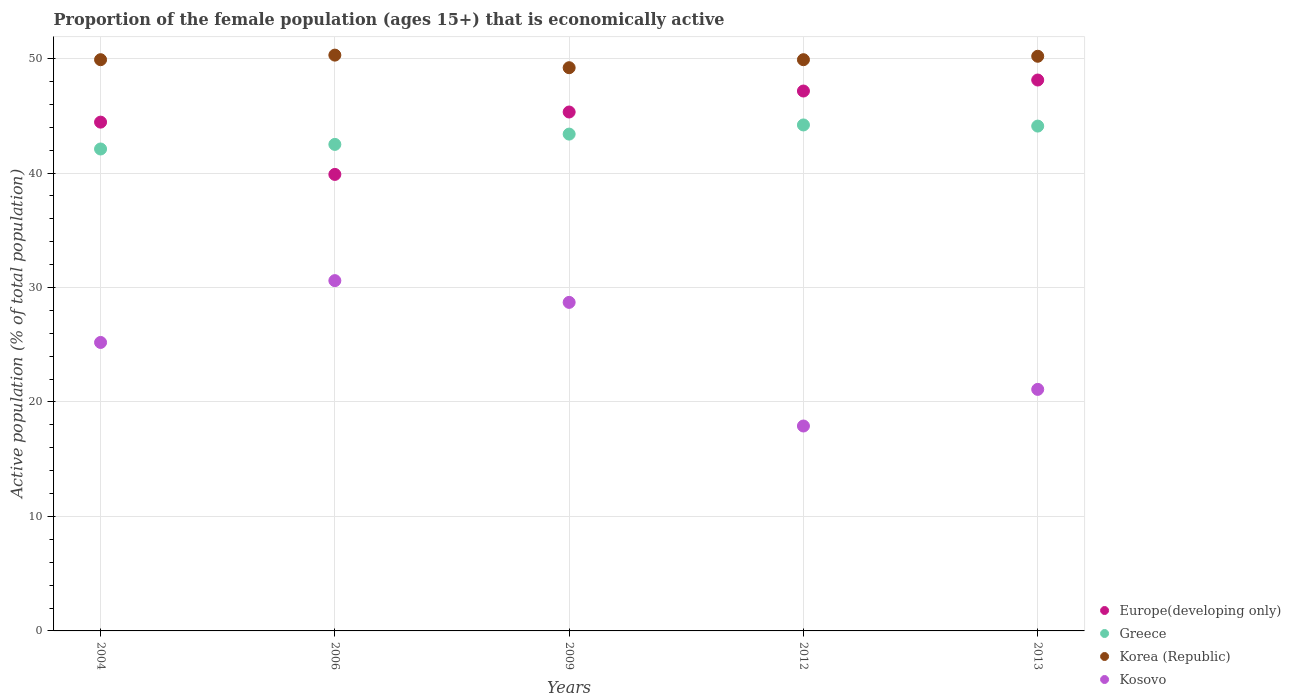What is the proportion of the female population that is economically active in Europe(developing only) in 2004?
Keep it short and to the point. 44.45. Across all years, what is the maximum proportion of the female population that is economically active in Europe(developing only)?
Your answer should be very brief. 48.12. Across all years, what is the minimum proportion of the female population that is economically active in Greece?
Offer a very short reply. 42.1. What is the total proportion of the female population that is economically active in Europe(developing only) in the graph?
Your answer should be compact. 224.94. What is the difference between the proportion of the female population that is economically active in Europe(developing only) in 2004 and that in 2012?
Offer a very short reply. -2.72. What is the difference between the proportion of the female population that is economically active in Kosovo in 2004 and the proportion of the female population that is economically active in Korea (Republic) in 2012?
Keep it short and to the point. -24.7. What is the average proportion of the female population that is economically active in Korea (Republic) per year?
Give a very brief answer. 49.9. In the year 2012, what is the difference between the proportion of the female population that is economically active in Europe(developing only) and proportion of the female population that is economically active in Kosovo?
Provide a succinct answer. 29.26. What is the ratio of the proportion of the female population that is economically active in Greece in 2004 to that in 2012?
Provide a succinct answer. 0.95. Is the proportion of the female population that is economically active in Greece in 2004 less than that in 2012?
Keep it short and to the point. Yes. Is the difference between the proportion of the female population that is economically active in Europe(developing only) in 2004 and 2009 greater than the difference between the proportion of the female population that is economically active in Kosovo in 2004 and 2009?
Provide a short and direct response. Yes. What is the difference between the highest and the second highest proportion of the female population that is economically active in Korea (Republic)?
Provide a short and direct response. 0.1. What is the difference between the highest and the lowest proportion of the female population that is economically active in Kosovo?
Ensure brevity in your answer.  12.7. In how many years, is the proportion of the female population that is economically active in Greece greater than the average proportion of the female population that is economically active in Greece taken over all years?
Your answer should be compact. 3. Is the sum of the proportion of the female population that is economically active in Korea (Republic) in 2009 and 2012 greater than the maximum proportion of the female population that is economically active in Europe(developing only) across all years?
Give a very brief answer. Yes. Is it the case that in every year, the sum of the proportion of the female population that is economically active in Korea (Republic) and proportion of the female population that is economically active in Greece  is greater than the sum of proportion of the female population that is economically active in Europe(developing only) and proportion of the female population that is economically active in Kosovo?
Make the answer very short. Yes. Is it the case that in every year, the sum of the proportion of the female population that is economically active in Kosovo and proportion of the female population that is economically active in Korea (Republic)  is greater than the proportion of the female population that is economically active in Greece?
Your answer should be compact. Yes. Is the proportion of the female population that is economically active in Europe(developing only) strictly greater than the proportion of the female population that is economically active in Greece over the years?
Keep it short and to the point. No. Is the proportion of the female population that is economically active in Kosovo strictly less than the proportion of the female population that is economically active in Greece over the years?
Provide a succinct answer. Yes. How many dotlines are there?
Make the answer very short. 4. How many years are there in the graph?
Make the answer very short. 5. What is the difference between two consecutive major ticks on the Y-axis?
Keep it short and to the point. 10. Are the values on the major ticks of Y-axis written in scientific E-notation?
Provide a succinct answer. No. Does the graph contain any zero values?
Your answer should be very brief. No. Where does the legend appear in the graph?
Keep it short and to the point. Bottom right. How are the legend labels stacked?
Give a very brief answer. Vertical. What is the title of the graph?
Your answer should be very brief. Proportion of the female population (ages 15+) that is economically active. What is the label or title of the Y-axis?
Keep it short and to the point. Active population (% of total population). What is the Active population (% of total population) in Europe(developing only) in 2004?
Your answer should be very brief. 44.45. What is the Active population (% of total population) in Greece in 2004?
Offer a very short reply. 42.1. What is the Active population (% of total population) of Korea (Republic) in 2004?
Give a very brief answer. 49.9. What is the Active population (% of total population) of Kosovo in 2004?
Give a very brief answer. 25.2. What is the Active population (% of total population) in Europe(developing only) in 2006?
Offer a very short reply. 39.88. What is the Active population (% of total population) of Greece in 2006?
Your answer should be compact. 42.5. What is the Active population (% of total population) in Korea (Republic) in 2006?
Provide a short and direct response. 50.3. What is the Active population (% of total population) in Kosovo in 2006?
Your answer should be very brief. 30.6. What is the Active population (% of total population) in Europe(developing only) in 2009?
Your answer should be compact. 45.33. What is the Active population (% of total population) in Greece in 2009?
Your answer should be compact. 43.4. What is the Active population (% of total population) of Korea (Republic) in 2009?
Give a very brief answer. 49.2. What is the Active population (% of total population) in Kosovo in 2009?
Ensure brevity in your answer.  28.7. What is the Active population (% of total population) of Europe(developing only) in 2012?
Offer a very short reply. 47.16. What is the Active population (% of total population) of Greece in 2012?
Provide a succinct answer. 44.2. What is the Active population (% of total population) of Korea (Republic) in 2012?
Provide a short and direct response. 49.9. What is the Active population (% of total population) of Kosovo in 2012?
Offer a terse response. 17.9. What is the Active population (% of total population) in Europe(developing only) in 2013?
Provide a short and direct response. 48.12. What is the Active population (% of total population) of Greece in 2013?
Your answer should be compact. 44.1. What is the Active population (% of total population) in Korea (Republic) in 2013?
Your answer should be compact. 50.2. What is the Active population (% of total population) in Kosovo in 2013?
Make the answer very short. 21.1. Across all years, what is the maximum Active population (% of total population) of Europe(developing only)?
Provide a short and direct response. 48.12. Across all years, what is the maximum Active population (% of total population) of Greece?
Ensure brevity in your answer.  44.2. Across all years, what is the maximum Active population (% of total population) of Korea (Republic)?
Offer a very short reply. 50.3. Across all years, what is the maximum Active population (% of total population) in Kosovo?
Provide a succinct answer. 30.6. Across all years, what is the minimum Active population (% of total population) of Europe(developing only)?
Your answer should be very brief. 39.88. Across all years, what is the minimum Active population (% of total population) of Greece?
Your answer should be compact. 42.1. Across all years, what is the minimum Active population (% of total population) in Korea (Republic)?
Give a very brief answer. 49.2. Across all years, what is the minimum Active population (% of total population) in Kosovo?
Provide a succinct answer. 17.9. What is the total Active population (% of total population) of Europe(developing only) in the graph?
Keep it short and to the point. 224.94. What is the total Active population (% of total population) in Greece in the graph?
Your answer should be compact. 216.3. What is the total Active population (% of total population) in Korea (Republic) in the graph?
Make the answer very short. 249.5. What is the total Active population (% of total population) in Kosovo in the graph?
Make the answer very short. 123.5. What is the difference between the Active population (% of total population) of Europe(developing only) in 2004 and that in 2006?
Make the answer very short. 4.57. What is the difference between the Active population (% of total population) in Greece in 2004 and that in 2006?
Make the answer very short. -0.4. What is the difference between the Active population (% of total population) of Korea (Republic) in 2004 and that in 2006?
Ensure brevity in your answer.  -0.4. What is the difference between the Active population (% of total population) in Kosovo in 2004 and that in 2006?
Make the answer very short. -5.4. What is the difference between the Active population (% of total population) in Europe(developing only) in 2004 and that in 2009?
Ensure brevity in your answer.  -0.88. What is the difference between the Active population (% of total population) in Korea (Republic) in 2004 and that in 2009?
Your answer should be very brief. 0.7. What is the difference between the Active population (% of total population) in Europe(developing only) in 2004 and that in 2012?
Offer a terse response. -2.72. What is the difference between the Active population (% of total population) in Greece in 2004 and that in 2012?
Make the answer very short. -2.1. What is the difference between the Active population (% of total population) of Europe(developing only) in 2004 and that in 2013?
Provide a succinct answer. -3.68. What is the difference between the Active population (% of total population) of Kosovo in 2004 and that in 2013?
Provide a short and direct response. 4.1. What is the difference between the Active population (% of total population) in Europe(developing only) in 2006 and that in 2009?
Your response must be concise. -5.45. What is the difference between the Active population (% of total population) in Greece in 2006 and that in 2009?
Your response must be concise. -0.9. What is the difference between the Active population (% of total population) in Korea (Republic) in 2006 and that in 2009?
Your answer should be compact. 1.1. What is the difference between the Active population (% of total population) of Europe(developing only) in 2006 and that in 2012?
Your response must be concise. -7.29. What is the difference between the Active population (% of total population) in Greece in 2006 and that in 2012?
Ensure brevity in your answer.  -1.7. What is the difference between the Active population (% of total population) in Kosovo in 2006 and that in 2012?
Offer a terse response. 12.7. What is the difference between the Active population (% of total population) of Europe(developing only) in 2006 and that in 2013?
Offer a very short reply. -8.25. What is the difference between the Active population (% of total population) of Korea (Republic) in 2006 and that in 2013?
Make the answer very short. 0.1. What is the difference between the Active population (% of total population) of Europe(developing only) in 2009 and that in 2012?
Provide a succinct answer. -1.83. What is the difference between the Active population (% of total population) of Greece in 2009 and that in 2012?
Provide a succinct answer. -0.8. What is the difference between the Active population (% of total population) of Korea (Republic) in 2009 and that in 2012?
Your answer should be very brief. -0.7. What is the difference between the Active population (% of total population) of Kosovo in 2009 and that in 2012?
Your response must be concise. 10.8. What is the difference between the Active population (% of total population) in Europe(developing only) in 2009 and that in 2013?
Give a very brief answer. -2.79. What is the difference between the Active population (% of total population) in Kosovo in 2009 and that in 2013?
Your answer should be very brief. 7.6. What is the difference between the Active population (% of total population) in Europe(developing only) in 2012 and that in 2013?
Your answer should be compact. -0.96. What is the difference between the Active population (% of total population) in Kosovo in 2012 and that in 2013?
Offer a terse response. -3.2. What is the difference between the Active population (% of total population) of Europe(developing only) in 2004 and the Active population (% of total population) of Greece in 2006?
Keep it short and to the point. 1.95. What is the difference between the Active population (% of total population) of Europe(developing only) in 2004 and the Active population (% of total population) of Korea (Republic) in 2006?
Provide a succinct answer. -5.85. What is the difference between the Active population (% of total population) of Europe(developing only) in 2004 and the Active population (% of total population) of Kosovo in 2006?
Your answer should be compact. 13.85. What is the difference between the Active population (% of total population) in Greece in 2004 and the Active population (% of total population) in Kosovo in 2006?
Offer a terse response. 11.5. What is the difference between the Active population (% of total population) in Korea (Republic) in 2004 and the Active population (% of total population) in Kosovo in 2006?
Provide a short and direct response. 19.3. What is the difference between the Active population (% of total population) in Europe(developing only) in 2004 and the Active population (% of total population) in Greece in 2009?
Your response must be concise. 1.05. What is the difference between the Active population (% of total population) in Europe(developing only) in 2004 and the Active population (% of total population) in Korea (Republic) in 2009?
Your answer should be very brief. -4.75. What is the difference between the Active population (% of total population) in Europe(developing only) in 2004 and the Active population (% of total population) in Kosovo in 2009?
Keep it short and to the point. 15.75. What is the difference between the Active population (% of total population) in Korea (Republic) in 2004 and the Active population (% of total population) in Kosovo in 2009?
Keep it short and to the point. 21.2. What is the difference between the Active population (% of total population) of Europe(developing only) in 2004 and the Active population (% of total population) of Greece in 2012?
Offer a very short reply. 0.25. What is the difference between the Active population (% of total population) of Europe(developing only) in 2004 and the Active population (% of total population) of Korea (Republic) in 2012?
Ensure brevity in your answer.  -5.45. What is the difference between the Active population (% of total population) in Europe(developing only) in 2004 and the Active population (% of total population) in Kosovo in 2012?
Keep it short and to the point. 26.55. What is the difference between the Active population (% of total population) in Greece in 2004 and the Active population (% of total population) in Korea (Republic) in 2012?
Ensure brevity in your answer.  -7.8. What is the difference between the Active population (% of total population) in Greece in 2004 and the Active population (% of total population) in Kosovo in 2012?
Provide a short and direct response. 24.2. What is the difference between the Active population (% of total population) in Europe(developing only) in 2004 and the Active population (% of total population) in Greece in 2013?
Provide a short and direct response. 0.35. What is the difference between the Active population (% of total population) of Europe(developing only) in 2004 and the Active population (% of total population) of Korea (Republic) in 2013?
Offer a terse response. -5.75. What is the difference between the Active population (% of total population) in Europe(developing only) in 2004 and the Active population (% of total population) in Kosovo in 2013?
Provide a short and direct response. 23.35. What is the difference between the Active population (% of total population) in Greece in 2004 and the Active population (% of total population) in Kosovo in 2013?
Offer a very short reply. 21. What is the difference between the Active population (% of total population) in Korea (Republic) in 2004 and the Active population (% of total population) in Kosovo in 2013?
Your response must be concise. 28.8. What is the difference between the Active population (% of total population) of Europe(developing only) in 2006 and the Active population (% of total population) of Greece in 2009?
Your answer should be compact. -3.52. What is the difference between the Active population (% of total population) of Europe(developing only) in 2006 and the Active population (% of total population) of Korea (Republic) in 2009?
Make the answer very short. -9.32. What is the difference between the Active population (% of total population) in Europe(developing only) in 2006 and the Active population (% of total population) in Kosovo in 2009?
Provide a succinct answer. 11.18. What is the difference between the Active population (% of total population) of Korea (Republic) in 2006 and the Active population (% of total population) of Kosovo in 2009?
Ensure brevity in your answer.  21.6. What is the difference between the Active population (% of total population) of Europe(developing only) in 2006 and the Active population (% of total population) of Greece in 2012?
Your answer should be compact. -4.32. What is the difference between the Active population (% of total population) of Europe(developing only) in 2006 and the Active population (% of total population) of Korea (Republic) in 2012?
Offer a very short reply. -10.02. What is the difference between the Active population (% of total population) of Europe(developing only) in 2006 and the Active population (% of total population) of Kosovo in 2012?
Offer a terse response. 21.98. What is the difference between the Active population (% of total population) in Greece in 2006 and the Active population (% of total population) in Kosovo in 2012?
Offer a very short reply. 24.6. What is the difference between the Active population (% of total population) in Korea (Republic) in 2006 and the Active population (% of total population) in Kosovo in 2012?
Offer a terse response. 32.4. What is the difference between the Active population (% of total population) of Europe(developing only) in 2006 and the Active population (% of total population) of Greece in 2013?
Give a very brief answer. -4.22. What is the difference between the Active population (% of total population) of Europe(developing only) in 2006 and the Active population (% of total population) of Korea (Republic) in 2013?
Ensure brevity in your answer.  -10.32. What is the difference between the Active population (% of total population) in Europe(developing only) in 2006 and the Active population (% of total population) in Kosovo in 2013?
Give a very brief answer. 18.78. What is the difference between the Active population (% of total population) of Greece in 2006 and the Active population (% of total population) of Kosovo in 2013?
Provide a short and direct response. 21.4. What is the difference between the Active population (% of total population) in Korea (Republic) in 2006 and the Active population (% of total population) in Kosovo in 2013?
Your answer should be very brief. 29.2. What is the difference between the Active population (% of total population) of Europe(developing only) in 2009 and the Active population (% of total population) of Greece in 2012?
Your response must be concise. 1.13. What is the difference between the Active population (% of total population) in Europe(developing only) in 2009 and the Active population (% of total population) in Korea (Republic) in 2012?
Your answer should be very brief. -4.57. What is the difference between the Active population (% of total population) in Europe(developing only) in 2009 and the Active population (% of total population) in Kosovo in 2012?
Provide a short and direct response. 27.43. What is the difference between the Active population (% of total population) in Greece in 2009 and the Active population (% of total population) in Korea (Republic) in 2012?
Keep it short and to the point. -6.5. What is the difference between the Active population (% of total population) in Korea (Republic) in 2009 and the Active population (% of total population) in Kosovo in 2012?
Offer a terse response. 31.3. What is the difference between the Active population (% of total population) in Europe(developing only) in 2009 and the Active population (% of total population) in Greece in 2013?
Keep it short and to the point. 1.23. What is the difference between the Active population (% of total population) of Europe(developing only) in 2009 and the Active population (% of total population) of Korea (Republic) in 2013?
Provide a succinct answer. -4.87. What is the difference between the Active population (% of total population) in Europe(developing only) in 2009 and the Active population (% of total population) in Kosovo in 2013?
Give a very brief answer. 24.23. What is the difference between the Active population (% of total population) of Greece in 2009 and the Active population (% of total population) of Kosovo in 2013?
Your answer should be very brief. 22.3. What is the difference between the Active population (% of total population) in Korea (Republic) in 2009 and the Active population (% of total population) in Kosovo in 2013?
Offer a terse response. 28.1. What is the difference between the Active population (% of total population) of Europe(developing only) in 2012 and the Active population (% of total population) of Greece in 2013?
Offer a terse response. 3.06. What is the difference between the Active population (% of total population) in Europe(developing only) in 2012 and the Active population (% of total population) in Korea (Republic) in 2013?
Your response must be concise. -3.04. What is the difference between the Active population (% of total population) of Europe(developing only) in 2012 and the Active population (% of total population) of Kosovo in 2013?
Your answer should be very brief. 26.06. What is the difference between the Active population (% of total population) of Greece in 2012 and the Active population (% of total population) of Kosovo in 2013?
Offer a very short reply. 23.1. What is the difference between the Active population (% of total population) of Korea (Republic) in 2012 and the Active population (% of total population) of Kosovo in 2013?
Offer a very short reply. 28.8. What is the average Active population (% of total population) of Europe(developing only) per year?
Keep it short and to the point. 44.99. What is the average Active population (% of total population) of Greece per year?
Offer a terse response. 43.26. What is the average Active population (% of total population) of Korea (Republic) per year?
Provide a succinct answer. 49.9. What is the average Active population (% of total population) of Kosovo per year?
Provide a succinct answer. 24.7. In the year 2004, what is the difference between the Active population (% of total population) in Europe(developing only) and Active population (% of total population) in Greece?
Your answer should be very brief. 2.35. In the year 2004, what is the difference between the Active population (% of total population) of Europe(developing only) and Active population (% of total population) of Korea (Republic)?
Your answer should be very brief. -5.45. In the year 2004, what is the difference between the Active population (% of total population) in Europe(developing only) and Active population (% of total population) in Kosovo?
Your answer should be compact. 19.25. In the year 2004, what is the difference between the Active population (% of total population) of Greece and Active population (% of total population) of Korea (Republic)?
Give a very brief answer. -7.8. In the year 2004, what is the difference between the Active population (% of total population) in Greece and Active population (% of total population) in Kosovo?
Keep it short and to the point. 16.9. In the year 2004, what is the difference between the Active population (% of total population) of Korea (Republic) and Active population (% of total population) of Kosovo?
Ensure brevity in your answer.  24.7. In the year 2006, what is the difference between the Active population (% of total population) in Europe(developing only) and Active population (% of total population) in Greece?
Offer a terse response. -2.62. In the year 2006, what is the difference between the Active population (% of total population) in Europe(developing only) and Active population (% of total population) in Korea (Republic)?
Your answer should be very brief. -10.42. In the year 2006, what is the difference between the Active population (% of total population) in Europe(developing only) and Active population (% of total population) in Kosovo?
Ensure brevity in your answer.  9.28. In the year 2006, what is the difference between the Active population (% of total population) of Greece and Active population (% of total population) of Kosovo?
Keep it short and to the point. 11.9. In the year 2009, what is the difference between the Active population (% of total population) in Europe(developing only) and Active population (% of total population) in Greece?
Make the answer very short. 1.93. In the year 2009, what is the difference between the Active population (% of total population) in Europe(developing only) and Active population (% of total population) in Korea (Republic)?
Keep it short and to the point. -3.87. In the year 2009, what is the difference between the Active population (% of total population) in Europe(developing only) and Active population (% of total population) in Kosovo?
Make the answer very short. 16.63. In the year 2009, what is the difference between the Active population (% of total population) of Greece and Active population (% of total population) of Korea (Republic)?
Keep it short and to the point. -5.8. In the year 2012, what is the difference between the Active population (% of total population) in Europe(developing only) and Active population (% of total population) in Greece?
Offer a terse response. 2.96. In the year 2012, what is the difference between the Active population (% of total population) of Europe(developing only) and Active population (% of total population) of Korea (Republic)?
Your response must be concise. -2.74. In the year 2012, what is the difference between the Active population (% of total population) in Europe(developing only) and Active population (% of total population) in Kosovo?
Your response must be concise. 29.26. In the year 2012, what is the difference between the Active population (% of total population) of Greece and Active population (% of total population) of Korea (Republic)?
Provide a short and direct response. -5.7. In the year 2012, what is the difference between the Active population (% of total population) in Greece and Active population (% of total population) in Kosovo?
Keep it short and to the point. 26.3. In the year 2013, what is the difference between the Active population (% of total population) in Europe(developing only) and Active population (% of total population) in Greece?
Provide a short and direct response. 4.02. In the year 2013, what is the difference between the Active population (% of total population) in Europe(developing only) and Active population (% of total population) in Korea (Republic)?
Your response must be concise. -2.08. In the year 2013, what is the difference between the Active population (% of total population) of Europe(developing only) and Active population (% of total population) of Kosovo?
Ensure brevity in your answer.  27.02. In the year 2013, what is the difference between the Active population (% of total population) in Greece and Active population (% of total population) in Korea (Republic)?
Give a very brief answer. -6.1. In the year 2013, what is the difference between the Active population (% of total population) in Korea (Republic) and Active population (% of total population) in Kosovo?
Ensure brevity in your answer.  29.1. What is the ratio of the Active population (% of total population) in Europe(developing only) in 2004 to that in 2006?
Ensure brevity in your answer.  1.11. What is the ratio of the Active population (% of total population) of Greece in 2004 to that in 2006?
Offer a terse response. 0.99. What is the ratio of the Active population (% of total population) in Kosovo in 2004 to that in 2006?
Give a very brief answer. 0.82. What is the ratio of the Active population (% of total population) in Europe(developing only) in 2004 to that in 2009?
Your answer should be compact. 0.98. What is the ratio of the Active population (% of total population) of Korea (Republic) in 2004 to that in 2009?
Keep it short and to the point. 1.01. What is the ratio of the Active population (% of total population) in Kosovo in 2004 to that in 2009?
Your answer should be compact. 0.88. What is the ratio of the Active population (% of total population) of Europe(developing only) in 2004 to that in 2012?
Provide a short and direct response. 0.94. What is the ratio of the Active population (% of total population) in Greece in 2004 to that in 2012?
Offer a terse response. 0.95. What is the ratio of the Active population (% of total population) in Korea (Republic) in 2004 to that in 2012?
Give a very brief answer. 1. What is the ratio of the Active population (% of total population) of Kosovo in 2004 to that in 2012?
Your answer should be very brief. 1.41. What is the ratio of the Active population (% of total population) of Europe(developing only) in 2004 to that in 2013?
Your response must be concise. 0.92. What is the ratio of the Active population (% of total population) in Greece in 2004 to that in 2013?
Your answer should be very brief. 0.95. What is the ratio of the Active population (% of total population) of Kosovo in 2004 to that in 2013?
Make the answer very short. 1.19. What is the ratio of the Active population (% of total population) of Europe(developing only) in 2006 to that in 2009?
Provide a short and direct response. 0.88. What is the ratio of the Active population (% of total population) in Greece in 2006 to that in 2009?
Keep it short and to the point. 0.98. What is the ratio of the Active population (% of total population) of Korea (Republic) in 2006 to that in 2009?
Provide a short and direct response. 1.02. What is the ratio of the Active population (% of total population) in Kosovo in 2006 to that in 2009?
Make the answer very short. 1.07. What is the ratio of the Active population (% of total population) in Europe(developing only) in 2006 to that in 2012?
Offer a terse response. 0.85. What is the ratio of the Active population (% of total population) of Greece in 2006 to that in 2012?
Your answer should be compact. 0.96. What is the ratio of the Active population (% of total population) of Kosovo in 2006 to that in 2012?
Make the answer very short. 1.71. What is the ratio of the Active population (% of total population) in Europe(developing only) in 2006 to that in 2013?
Provide a short and direct response. 0.83. What is the ratio of the Active population (% of total population) in Greece in 2006 to that in 2013?
Offer a very short reply. 0.96. What is the ratio of the Active population (% of total population) in Kosovo in 2006 to that in 2013?
Provide a succinct answer. 1.45. What is the ratio of the Active population (% of total population) in Europe(developing only) in 2009 to that in 2012?
Offer a terse response. 0.96. What is the ratio of the Active population (% of total population) in Greece in 2009 to that in 2012?
Give a very brief answer. 0.98. What is the ratio of the Active population (% of total population) of Korea (Republic) in 2009 to that in 2012?
Offer a terse response. 0.99. What is the ratio of the Active population (% of total population) in Kosovo in 2009 to that in 2012?
Offer a very short reply. 1.6. What is the ratio of the Active population (% of total population) in Europe(developing only) in 2009 to that in 2013?
Offer a very short reply. 0.94. What is the ratio of the Active population (% of total population) in Greece in 2009 to that in 2013?
Ensure brevity in your answer.  0.98. What is the ratio of the Active population (% of total population) of Korea (Republic) in 2009 to that in 2013?
Your answer should be very brief. 0.98. What is the ratio of the Active population (% of total population) of Kosovo in 2009 to that in 2013?
Your answer should be compact. 1.36. What is the ratio of the Active population (% of total population) in Kosovo in 2012 to that in 2013?
Your answer should be very brief. 0.85. What is the difference between the highest and the second highest Active population (% of total population) in Europe(developing only)?
Offer a very short reply. 0.96. What is the difference between the highest and the second highest Active population (% of total population) in Kosovo?
Give a very brief answer. 1.9. What is the difference between the highest and the lowest Active population (% of total population) of Europe(developing only)?
Your answer should be compact. 8.25. 